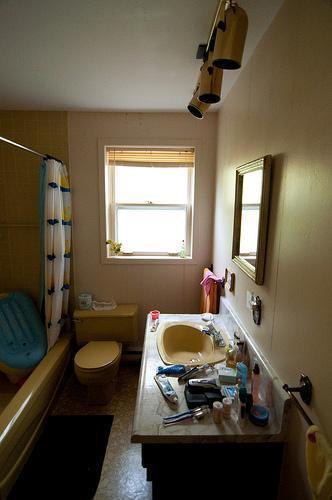How many windows are visible?
Give a very brief answer. 1. 